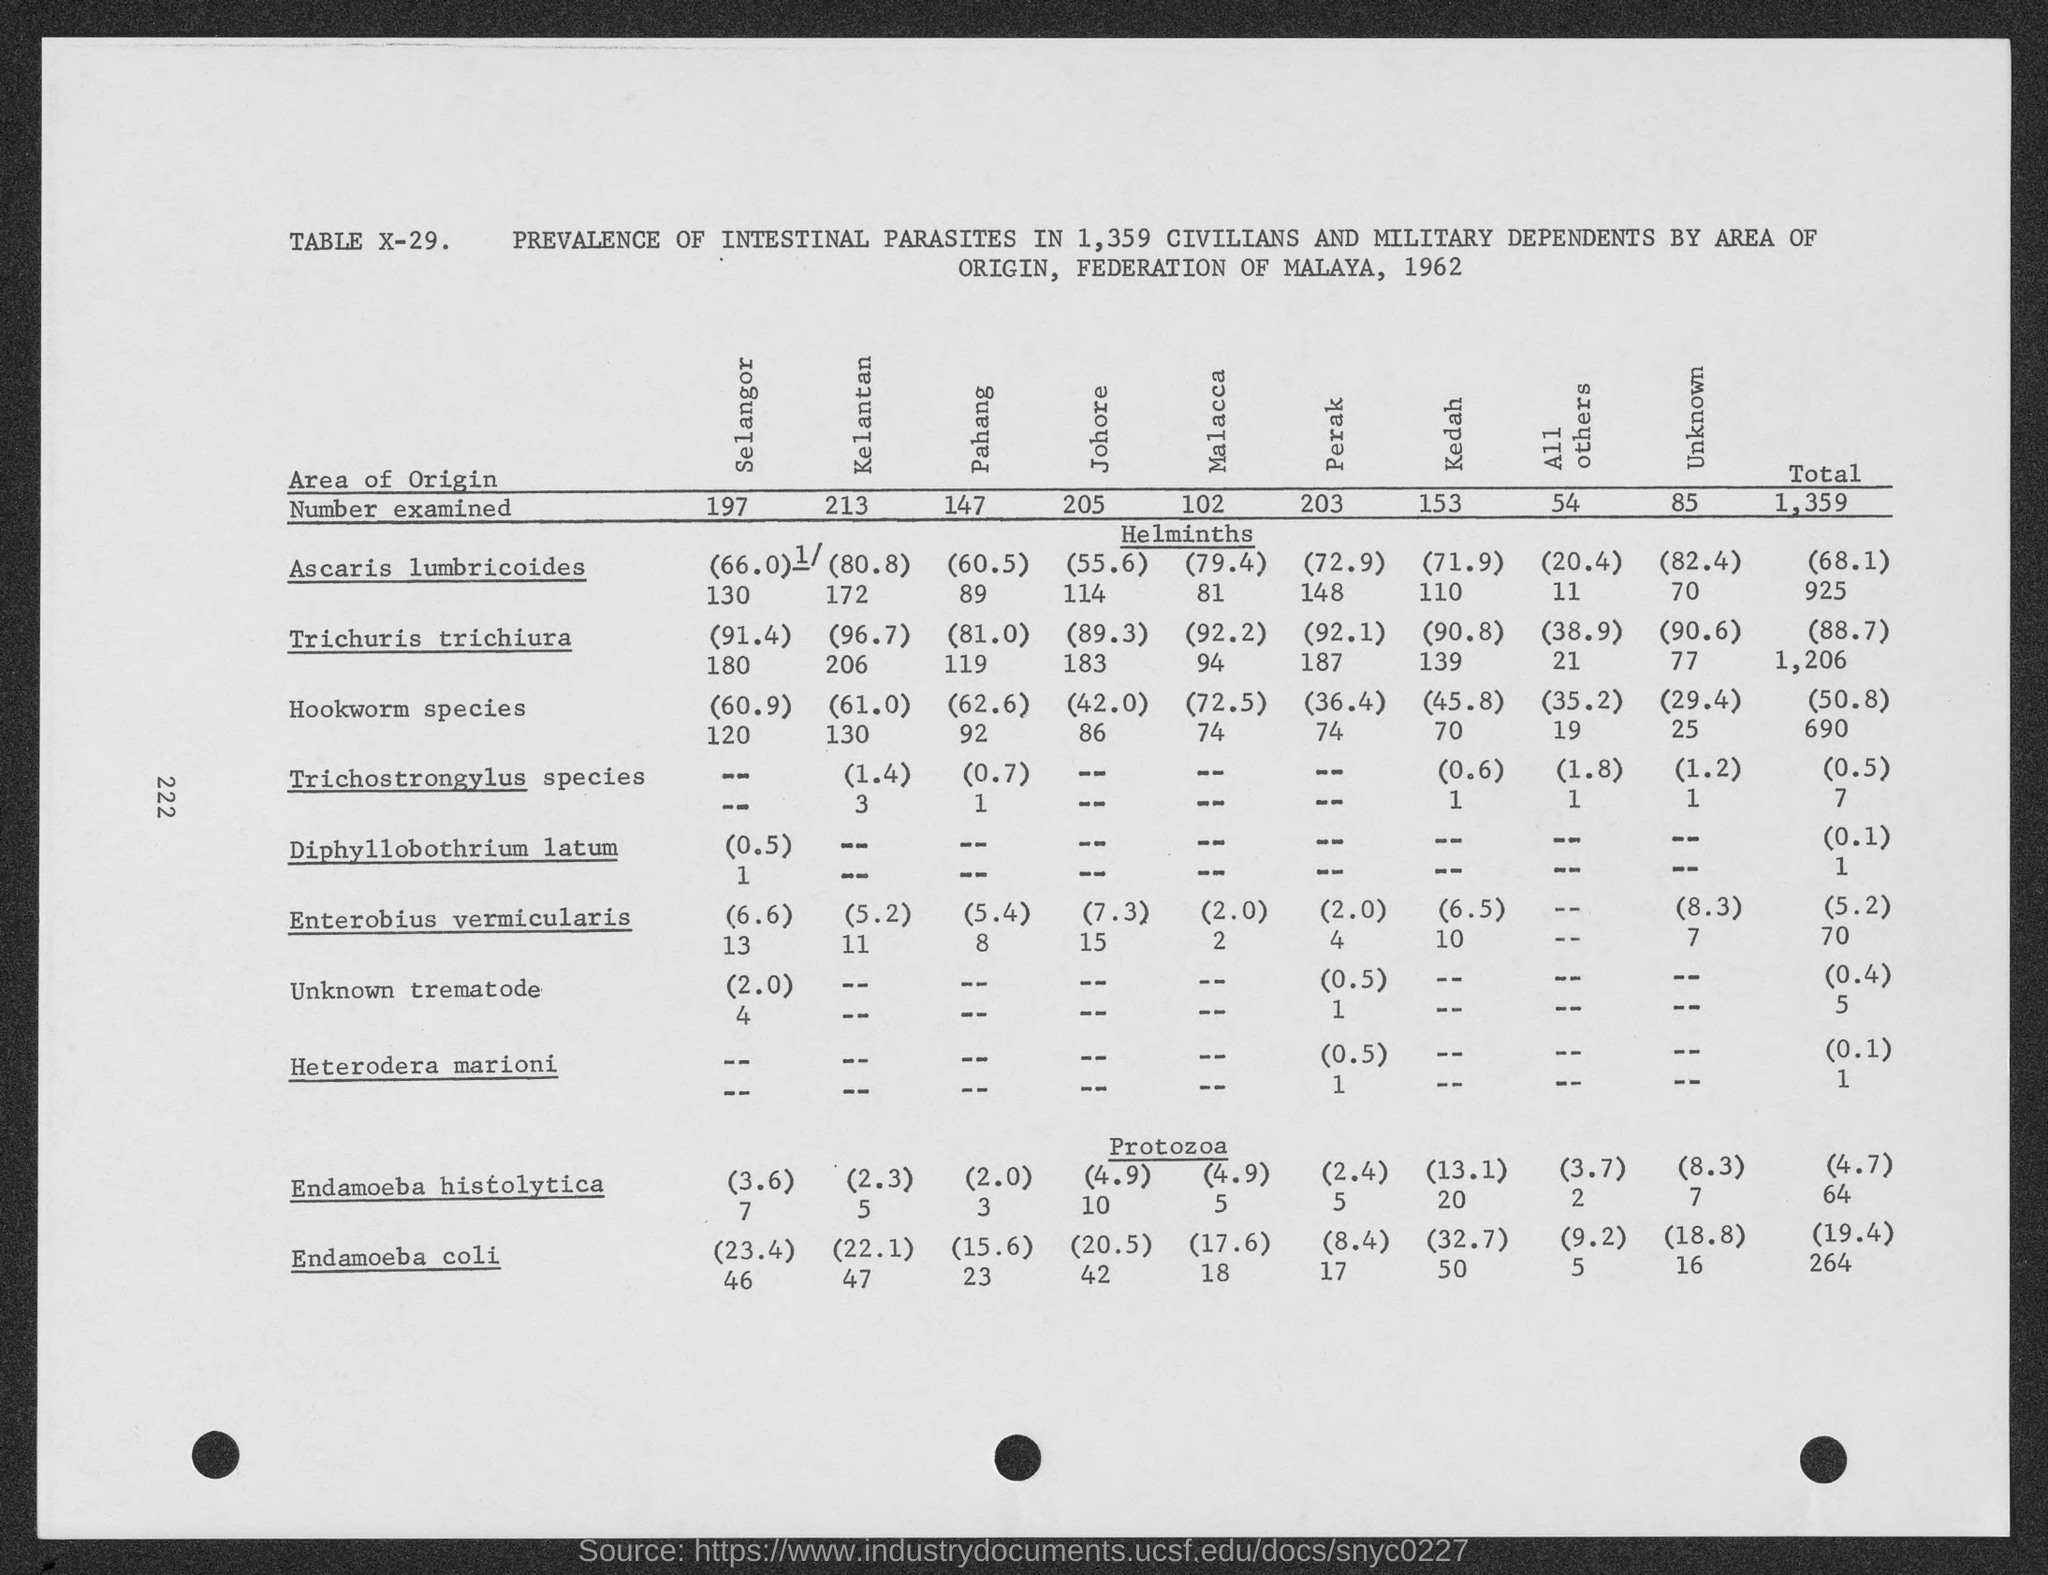Can you explain the significance of the data on Ascaris lumbricoides? Certainly! The table shows the percentage and number of individuals found with Ascaris lumbricoides among those examined in different regions. It highlights the distribution and impact of this parasitic roundworm infection on the population in 1962, which could be crucial for public health policies and determining where interventions may be needed. 